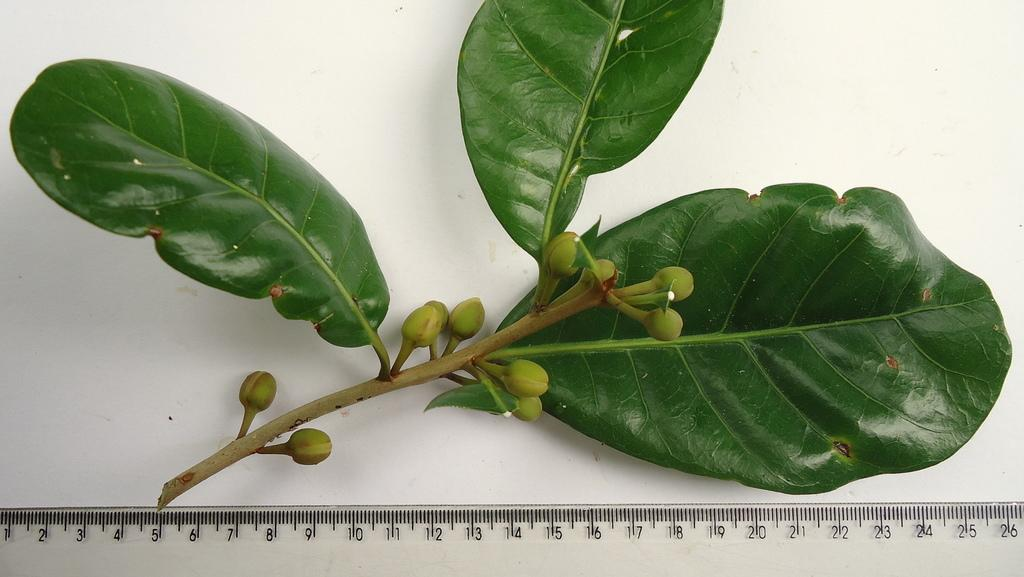What type of plant can be seen in the image? There is a green-colored plant in the image. What type of knowledge does the plant possess in the image? Plants do not possess knowledge, as they are living organisms and not capable of cognitive processes. 